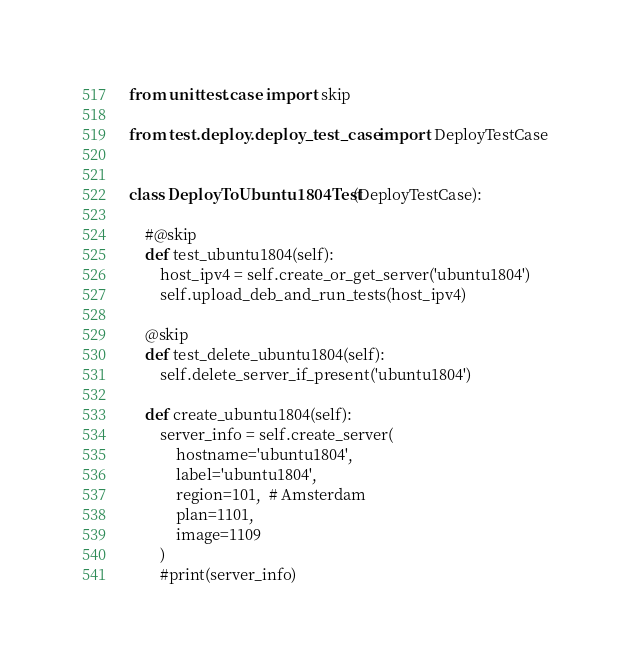Convert code to text. <code><loc_0><loc_0><loc_500><loc_500><_Python_>from unittest.case import skip

from test.deploy.deploy_test_case import DeployTestCase


class DeployToUbuntu1804Test(DeployTestCase):

    #@skip
    def test_ubuntu1804(self):
        host_ipv4 = self.create_or_get_server('ubuntu1804')
        self.upload_deb_and_run_tests(host_ipv4)

    @skip
    def test_delete_ubuntu1804(self):
        self.delete_server_if_present('ubuntu1804')

    def create_ubuntu1804(self):
        server_info = self.create_server(
            hostname='ubuntu1804',
            label='ubuntu1804',
            region=101,  # Amsterdam
            plan=1101,
            image=1109
        )
        #print(server_info)
</code> 